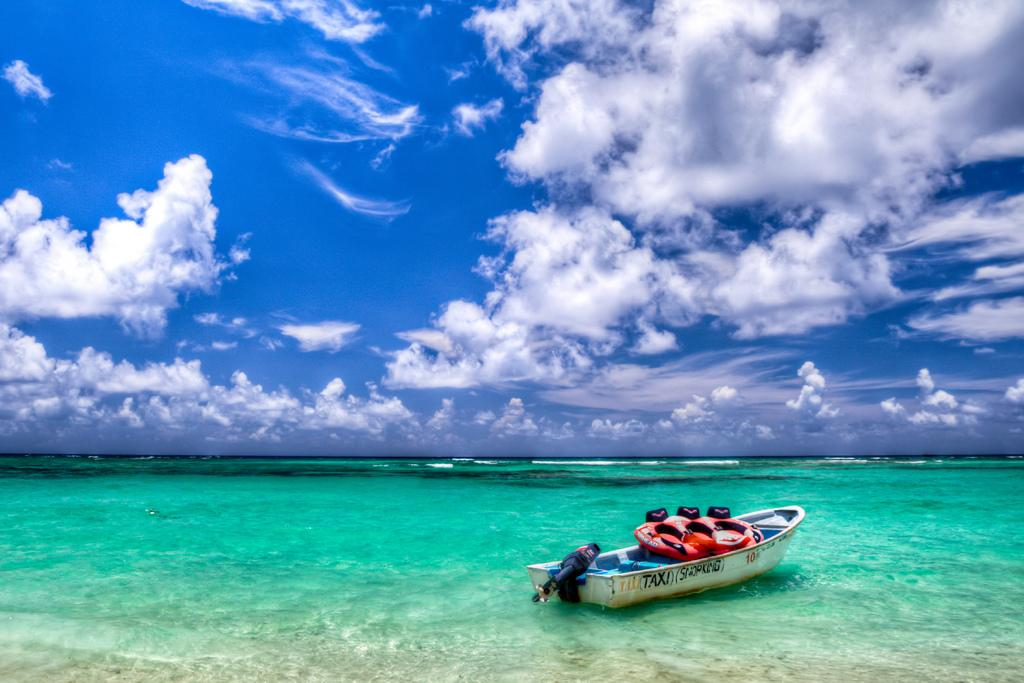<image>
Render a clear and concise summary of the photo. A kayak taxi in the water on the perfect summery cloudy day. 